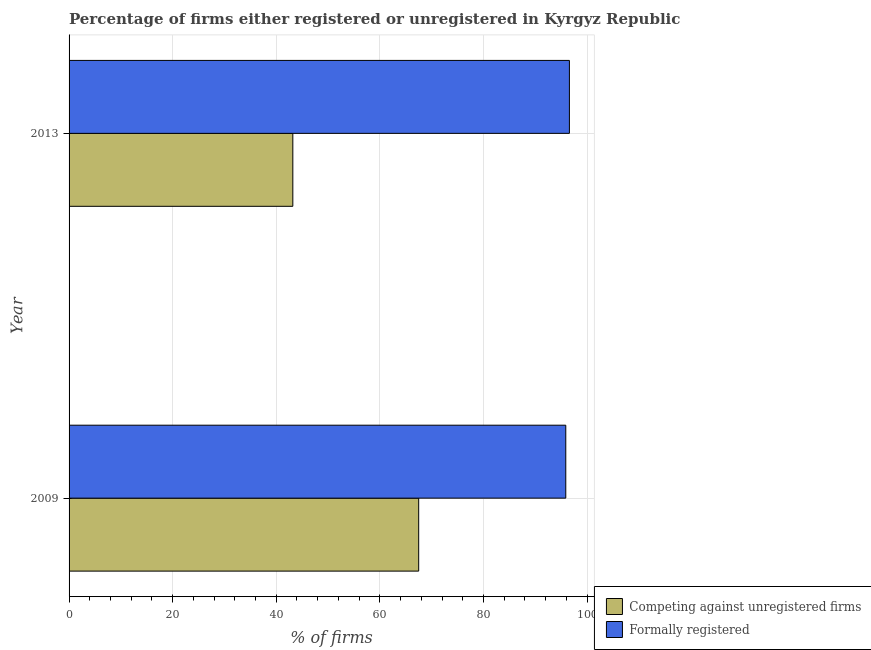Are the number of bars on each tick of the Y-axis equal?
Keep it short and to the point. Yes. How many bars are there on the 2nd tick from the top?
Ensure brevity in your answer.  2. How many bars are there on the 1st tick from the bottom?
Offer a terse response. 2. What is the label of the 1st group of bars from the top?
Your answer should be very brief. 2013. In how many cases, is the number of bars for a given year not equal to the number of legend labels?
Provide a short and direct response. 0. What is the percentage of registered firms in 2009?
Provide a short and direct response. 67.5. Across all years, what is the maximum percentage of formally registered firms?
Provide a short and direct response. 96.6. Across all years, what is the minimum percentage of registered firms?
Your answer should be very brief. 43.2. In which year was the percentage of formally registered firms maximum?
Make the answer very short. 2013. In which year was the percentage of registered firms minimum?
Give a very brief answer. 2013. What is the total percentage of registered firms in the graph?
Offer a very short reply. 110.7. What is the difference between the percentage of registered firms in 2009 and that in 2013?
Offer a terse response. 24.3. What is the difference between the percentage of registered firms in 2009 and the percentage of formally registered firms in 2013?
Provide a short and direct response. -29.1. What is the average percentage of registered firms per year?
Ensure brevity in your answer.  55.35. In the year 2013, what is the difference between the percentage of registered firms and percentage of formally registered firms?
Your answer should be very brief. -53.4. In how many years, is the percentage of formally registered firms greater than 68 %?
Provide a succinct answer. 2. What is the ratio of the percentage of registered firms in 2009 to that in 2013?
Keep it short and to the point. 1.56. Is the percentage of formally registered firms in 2009 less than that in 2013?
Keep it short and to the point. Yes. What does the 1st bar from the top in 2013 represents?
Provide a succinct answer. Formally registered. What does the 2nd bar from the bottom in 2013 represents?
Keep it short and to the point. Formally registered. Does the graph contain grids?
Your answer should be very brief. Yes. How many legend labels are there?
Provide a short and direct response. 2. What is the title of the graph?
Offer a very short reply. Percentage of firms either registered or unregistered in Kyrgyz Republic. What is the label or title of the X-axis?
Your answer should be very brief. % of firms. What is the % of firms in Competing against unregistered firms in 2009?
Give a very brief answer. 67.5. What is the % of firms of Formally registered in 2009?
Your answer should be very brief. 95.9. What is the % of firms of Competing against unregistered firms in 2013?
Make the answer very short. 43.2. What is the % of firms in Formally registered in 2013?
Keep it short and to the point. 96.6. Across all years, what is the maximum % of firms in Competing against unregistered firms?
Make the answer very short. 67.5. Across all years, what is the maximum % of firms of Formally registered?
Keep it short and to the point. 96.6. Across all years, what is the minimum % of firms of Competing against unregistered firms?
Provide a short and direct response. 43.2. Across all years, what is the minimum % of firms of Formally registered?
Offer a terse response. 95.9. What is the total % of firms in Competing against unregistered firms in the graph?
Offer a very short reply. 110.7. What is the total % of firms in Formally registered in the graph?
Ensure brevity in your answer.  192.5. What is the difference between the % of firms in Competing against unregistered firms in 2009 and that in 2013?
Offer a very short reply. 24.3. What is the difference between the % of firms in Formally registered in 2009 and that in 2013?
Provide a short and direct response. -0.7. What is the difference between the % of firms of Competing against unregistered firms in 2009 and the % of firms of Formally registered in 2013?
Provide a succinct answer. -29.1. What is the average % of firms of Competing against unregistered firms per year?
Ensure brevity in your answer.  55.35. What is the average % of firms in Formally registered per year?
Offer a very short reply. 96.25. In the year 2009, what is the difference between the % of firms of Competing against unregistered firms and % of firms of Formally registered?
Offer a terse response. -28.4. In the year 2013, what is the difference between the % of firms of Competing against unregistered firms and % of firms of Formally registered?
Give a very brief answer. -53.4. What is the ratio of the % of firms of Competing against unregistered firms in 2009 to that in 2013?
Give a very brief answer. 1.56. What is the difference between the highest and the second highest % of firms of Competing against unregistered firms?
Your answer should be very brief. 24.3. What is the difference between the highest and the lowest % of firms of Competing against unregistered firms?
Your answer should be compact. 24.3. What is the difference between the highest and the lowest % of firms of Formally registered?
Your answer should be very brief. 0.7. 